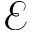Convert formula to latex. <formula><loc_0><loc_0><loc_500><loc_500>\mathcal { E }</formula> 